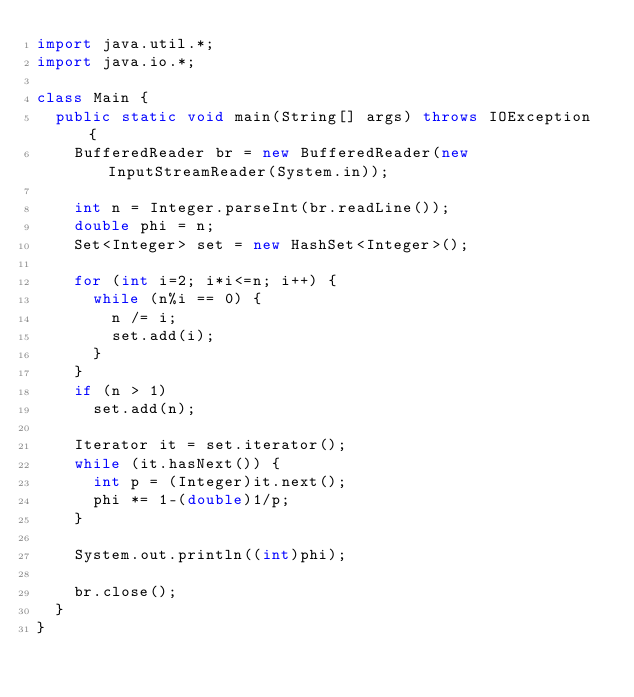Convert code to text. <code><loc_0><loc_0><loc_500><loc_500><_Java_>import java.util.*;
import java.io.*;

class Main {
	public static void main(String[] args) throws IOException {
		BufferedReader br = new BufferedReader(new InputStreamReader(System.in));

		int n = Integer.parseInt(br.readLine());
		double phi = n;
		Set<Integer> set = new HashSet<Integer>();

		for (int i=2; i*i<=n; i++) {
			while (n%i == 0) {
				n /= i;
				set.add(i);
			}
		}
		if (n > 1)
			set.add(n);

		Iterator it = set.iterator();
		while (it.hasNext()) {
			int p = (Integer)it.next();
			phi *= 1-(double)1/p;
		}

		System.out.println((int)phi);

		br.close();
	}
}</code> 